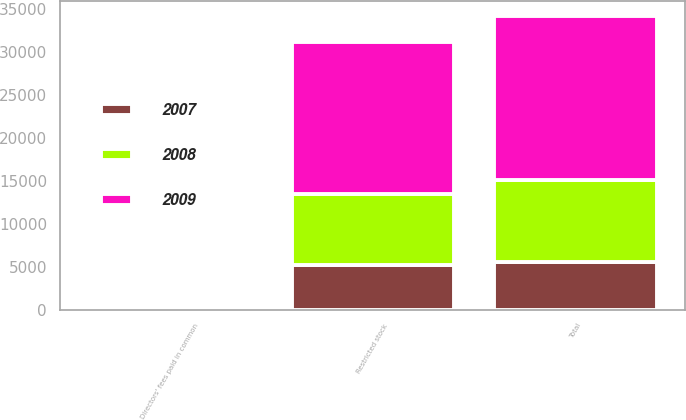<chart> <loc_0><loc_0><loc_500><loc_500><stacked_bar_chart><ecel><fcel>Restricted stock<fcel>Directors' fees paid in common<fcel>Total<nl><fcel>2007<fcel>5227<fcel>279<fcel>5506<nl><fcel>2008<fcel>8193<fcel>375<fcel>9556<nl><fcel>2009<fcel>17725<fcel>389<fcel>19138<nl></chart> 